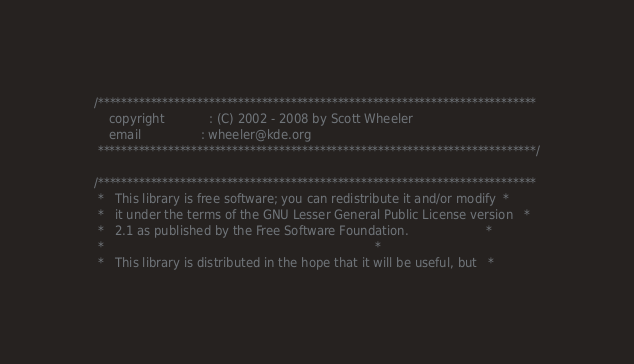<code> <loc_0><loc_0><loc_500><loc_500><_C_>/***************************************************************************
    copyright            : (C) 2002 - 2008 by Scott Wheeler
    email                : wheeler@kde.org
 ***************************************************************************/

/***************************************************************************
 *   This library is free software; you can redistribute it and/or modify  *
 *   it under the terms of the GNU Lesser General Public License version   *
 *   2.1 as published by the Free Software Foundation.                     *
 *                                                                         *
 *   This library is distributed in the hope that it will be useful, but   *</code> 